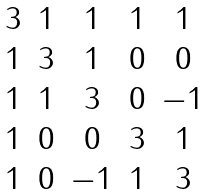<formula> <loc_0><loc_0><loc_500><loc_500>\begin{matrix} 3 & 1 & 1 & 1 & 1 \\ 1 & 3 & 1 & 0 & 0 \\ 1 & 1 & 3 & 0 & - 1 \\ 1 & 0 & 0 & 3 & 1 \\ 1 & 0 & - 1 & 1 & 3 \end{matrix}</formula> 